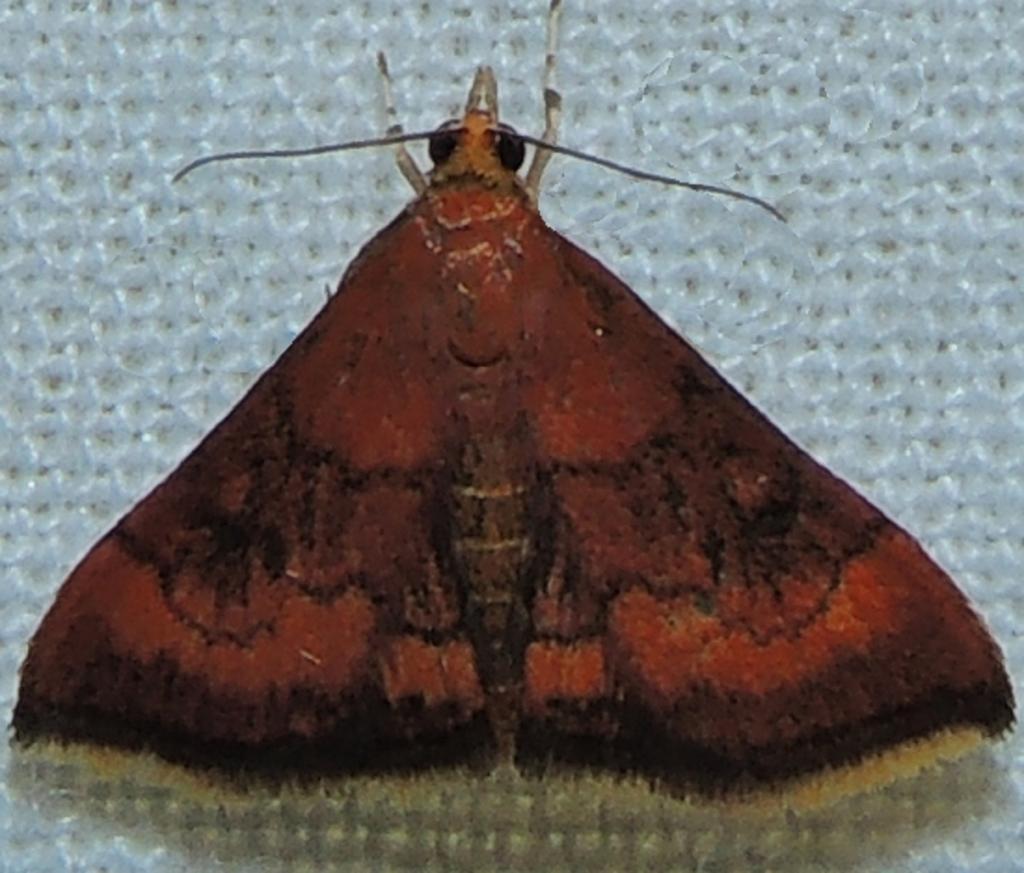Can you describe this image briefly? This picture contains an insect. It is in red color. In the background, it is white in color. 